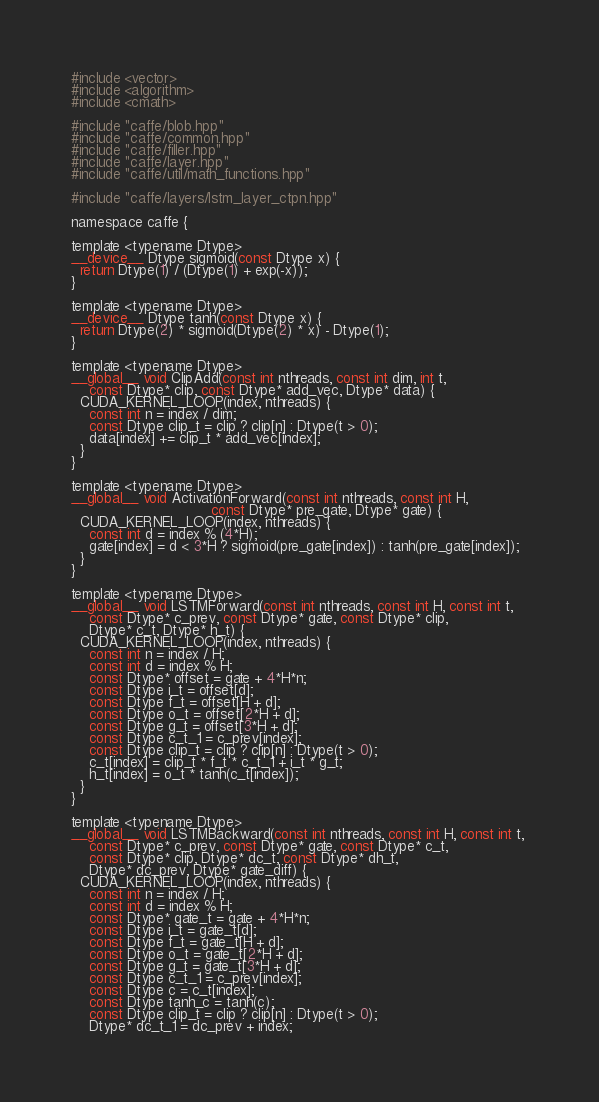Convert code to text. <code><loc_0><loc_0><loc_500><loc_500><_Cuda_>#include <vector>
#include <algorithm>
#include <cmath>

#include "caffe/blob.hpp"
#include "caffe/common.hpp"
#include "caffe/filler.hpp"
#include "caffe/layer.hpp"
#include "caffe/util/math_functions.hpp"

#include "caffe/layers/lstm_layer_ctpn.hpp"

namespace caffe {

template <typename Dtype>
__device__ Dtype sigmoid(const Dtype x) {
  return Dtype(1) / (Dtype(1) + exp(-x));
}

template <typename Dtype>
__device__ Dtype tanh(const Dtype x) {
  return Dtype(2) * sigmoid(Dtype(2) * x) - Dtype(1);
}

template <typename Dtype>
__global__ void ClipAdd(const int nthreads, const int dim, int t,
    const Dtype* clip, const Dtype* add_vec, Dtype* data) {
  CUDA_KERNEL_LOOP(index, nthreads) {
    const int n = index / dim;
    const Dtype clip_t = clip ? clip[n] : Dtype(t > 0);
    data[index] += clip_t * add_vec[index];
  }
}

template <typename Dtype>
__global__ void ActivationForward(const int nthreads, const int H,
                                const Dtype* pre_gate, Dtype* gate) {
  CUDA_KERNEL_LOOP(index, nthreads) {
    const int d = index % (4*H);
    gate[index] = d < 3*H ? sigmoid(pre_gate[index]) : tanh(pre_gate[index]);
  }
}

template <typename Dtype>
__global__ void LSTMForward(const int nthreads, const int H, const int t,
    const Dtype* c_prev, const Dtype* gate, const Dtype* clip,
    Dtype* c_t, Dtype* h_t) {
  CUDA_KERNEL_LOOP(index, nthreads) {
    const int n = index / H;
    const int d = index % H;
    const Dtype* offset = gate + 4*H*n;
    const Dtype i_t = offset[d];
    const Dtype f_t = offset[H + d];
    const Dtype o_t = offset[2*H + d];
    const Dtype g_t = offset[3*H + d];
    const Dtype c_t_1 = c_prev[index];
    const Dtype clip_t = clip ? clip[n] : Dtype(t > 0);
    c_t[index] = clip_t * f_t * c_t_1 + i_t * g_t;
    h_t[index] = o_t * tanh(c_t[index]);
  }
}

template <typename Dtype>
__global__ void LSTMBackward(const int nthreads, const int H, const int t, 
    const Dtype* c_prev, const Dtype* gate, const Dtype* c_t, 
    const Dtype* clip, Dtype* dc_t, const Dtype* dh_t, 
    Dtype* dc_prev, Dtype* gate_diff) {
  CUDA_KERNEL_LOOP(index, nthreads) {
    const int n = index / H;
    const int d = index % H;
    const Dtype* gate_t = gate + 4*H*n;
    const Dtype i_t = gate_t[d];
    const Dtype f_t = gate_t[H + d];
    const Dtype o_t = gate_t[2*H + d];
    const Dtype g_t = gate_t[3*H + d];
    const Dtype c_t_1 = c_prev[index];
    const Dtype c = c_t[index];
    const Dtype tanh_c = tanh(c);
    const Dtype clip_t = clip ? clip[n] : Dtype(t > 0);
    Dtype* dc_t_1 = dc_prev + index;</code> 